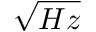Convert formula to latex. <formula><loc_0><loc_0><loc_500><loc_500>\sqrt { H z }</formula> 